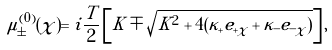Convert formula to latex. <formula><loc_0><loc_0><loc_500><loc_500>\mu _ { \pm } ^ { ( 0 ) } ( \chi ) = i \frac { T } { 2 } \left [ K \mp \sqrt { K ^ { 2 } + 4 ( \kappa _ { + } e _ { + \chi } + \kappa _ { - } e _ { - \chi } ) } \right ] ,</formula> 